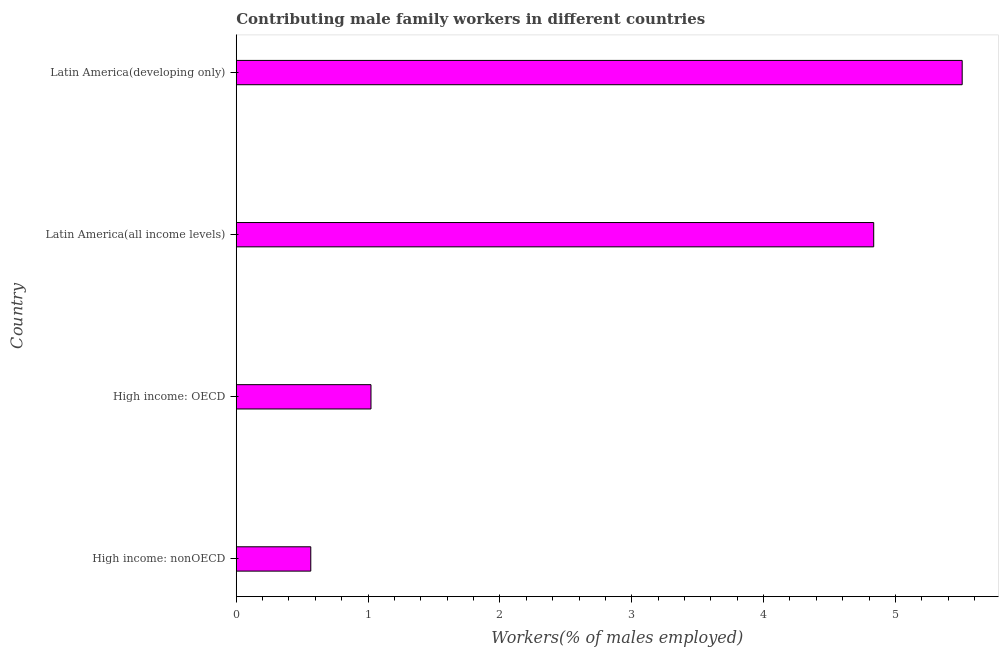What is the title of the graph?
Make the answer very short. Contributing male family workers in different countries. What is the label or title of the X-axis?
Offer a terse response. Workers(% of males employed). What is the label or title of the Y-axis?
Provide a succinct answer. Country. What is the contributing male family workers in High income: OECD?
Make the answer very short. 1.02. Across all countries, what is the maximum contributing male family workers?
Keep it short and to the point. 5.51. Across all countries, what is the minimum contributing male family workers?
Ensure brevity in your answer.  0.57. In which country was the contributing male family workers maximum?
Offer a terse response. Latin America(developing only). In which country was the contributing male family workers minimum?
Offer a very short reply. High income: nonOECD. What is the sum of the contributing male family workers?
Ensure brevity in your answer.  11.93. What is the difference between the contributing male family workers in High income: nonOECD and Latin America(developing only)?
Your response must be concise. -4.94. What is the average contributing male family workers per country?
Keep it short and to the point. 2.98. What is the median contributing male family workers?
Make the answer very short. 2.93. In how many countries, is the contributing male family workers greater than 3 %?
Your response must be concise. 2. What is the ratio of the contributing male family workers in High income: nonOECD to that in Latin America(developing only)?
Give a very brief answer. 0.1. Is the difference between the contributing male family workers in High income: nonOECD and Latin America(all income levels) greater than the difference between any two countries?
Your answer should be very brief. No. What is the difference between the highest and the second highest contributing male family workers?
Provide a short and direct response. 0.67. What is the difference between the highest and the lowest contributing male family workers?
Your response must be concise. 4.94. How many bars are there?
Your response must be concise. 4. Are all the bars in the graph horizontal?
Keep it short and to the point. Yes. What is the Workers(% of males employed) of High income: nonOECD?
Offer a very short reply. 0.57. What is the Workers(% of males employed) of High income: OECD?
Provide a short and direct response. 1.02. What is the Workers(% of males employed) in Latin America(all income levels)?
Keep it short and to the point. 4.84. What is the Workers(% of males employed) of Latin America(developing only)?
Offer a terse response. 5.51. What is the difference between the Workers(% of males employed) in High income: nonOECD and High income: OECD?
Your answer should be very brief. -0.46. What is the difference between the Workers(% of males employed) in High income: nonOECD and Latin America(all income levels)?
Offer a very short reply. -4.27. What is the difference between the Workers(% of males employed) in High income: nonOECD and Latin America(developing only)?
Provide a short and direct response. -4.94. What is the difference between the Workers(% of males employed) in High income: OECD and Latin America(all income levels)?
Your response must be concise. -3.81. What is the difference between the Workers(% of males employed) in High income: OECD and Latin America(developing only)?
Your response must be concise. -4.48. What is the difference between the Workers(% of males employed) in Latin America(all income levels) and Latin America(developing only)?
Provide a succinct answer. -0.67. What is the ratio of the Workers(% of males employed) in High income: nonOECD to that in High income: OECD?
Your response must be concise. 0.55. What is the ratio of the Workers(% of males employed) in High income: nonOECD to that in Latin America(all income levels)?
Make the answer very short. 0.12. What is the ratio of the Workers(% of males employed) in High income: nonOECD to that in Latin America(developing only)?
Your answer should be compact. 0.1. What is the ratio of the Workers(% of males employed) in High income: OECD to that in Latin America(all income levels)?
Offer a very short reply. 0.21. What is the ratio of the Workers(% of males employed) in High income: OECD to that in Latin America(developing only)?
Your answer should be compact. 0.19. What is the ratio of the Workers(% of males employed) in Latin America(all income levels) to that in Latin America(developing only)?
Your response must be concise. 0.88. 